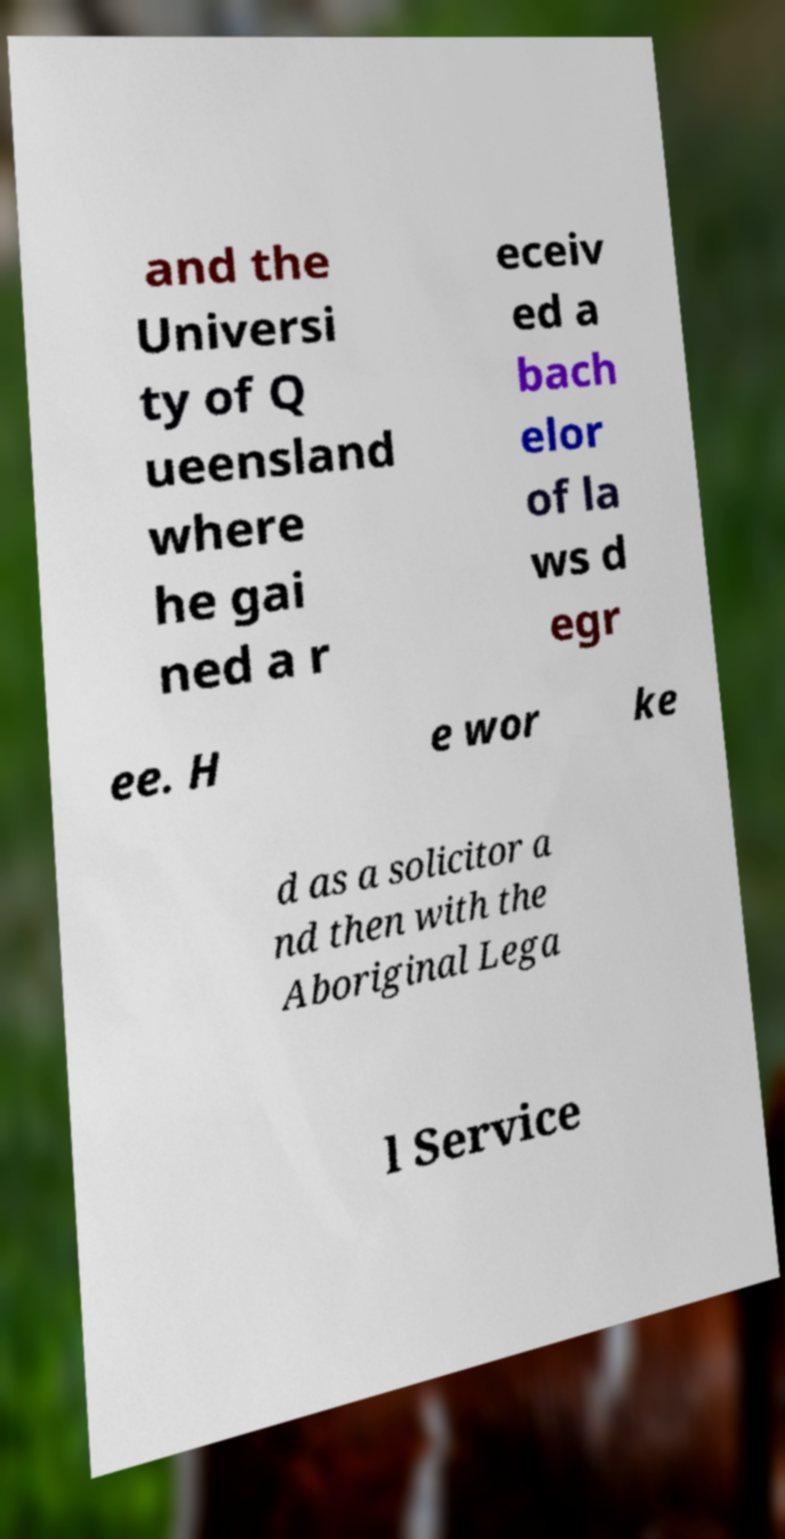What messages or text are displayed in this image? I need them in a readable, typed format. and the Universi ty of Q ueensland where he gai ned a r eceiv ed a bach elor of la ws d egr ee. H e wor ke d as a solicitor a nd then with the Aboriginal Lega l Service 